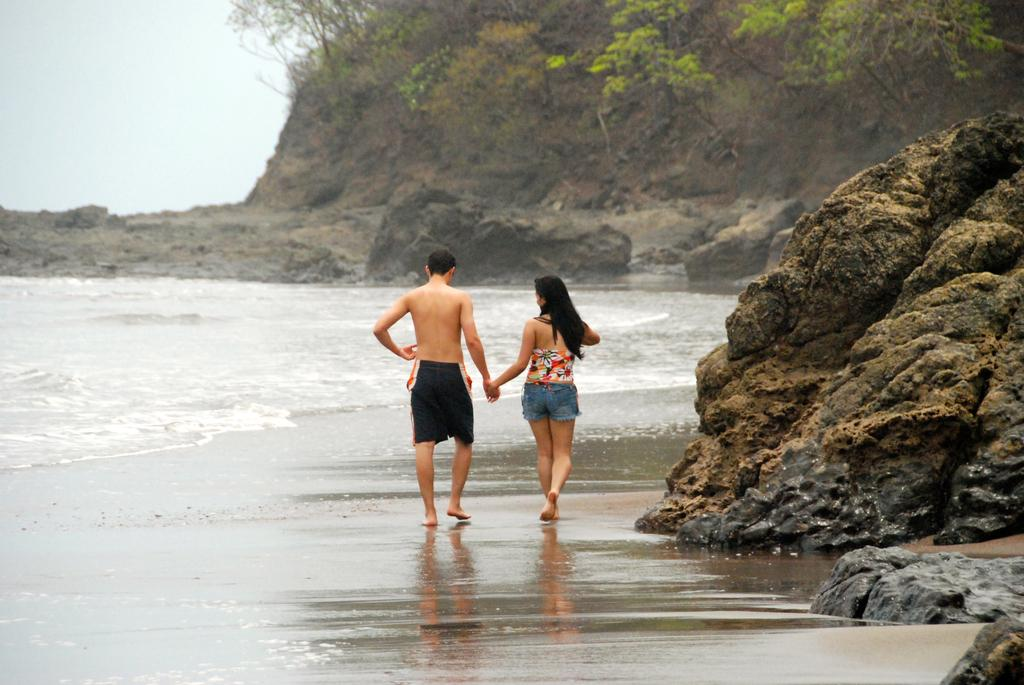How many people are present in the image? There are two people, a man and a woman, present in the image. What are the man and woman doing in the image? Both the man and woman are walking on the sea shore. What type of natural features can be seen in the image? There are rocks and trees visible in the image. What is visible on the left side of the image? The sky and water are visible on the left side of the image. What type of memory is being used by the man and woman in the image? There is no indication in the image that the man and woman are using any type of memory. What type of drink is being consumed by the man and woman in the image? There is no drink visible in the image, and it is not mentioned that the man and woman are consuming anything. 